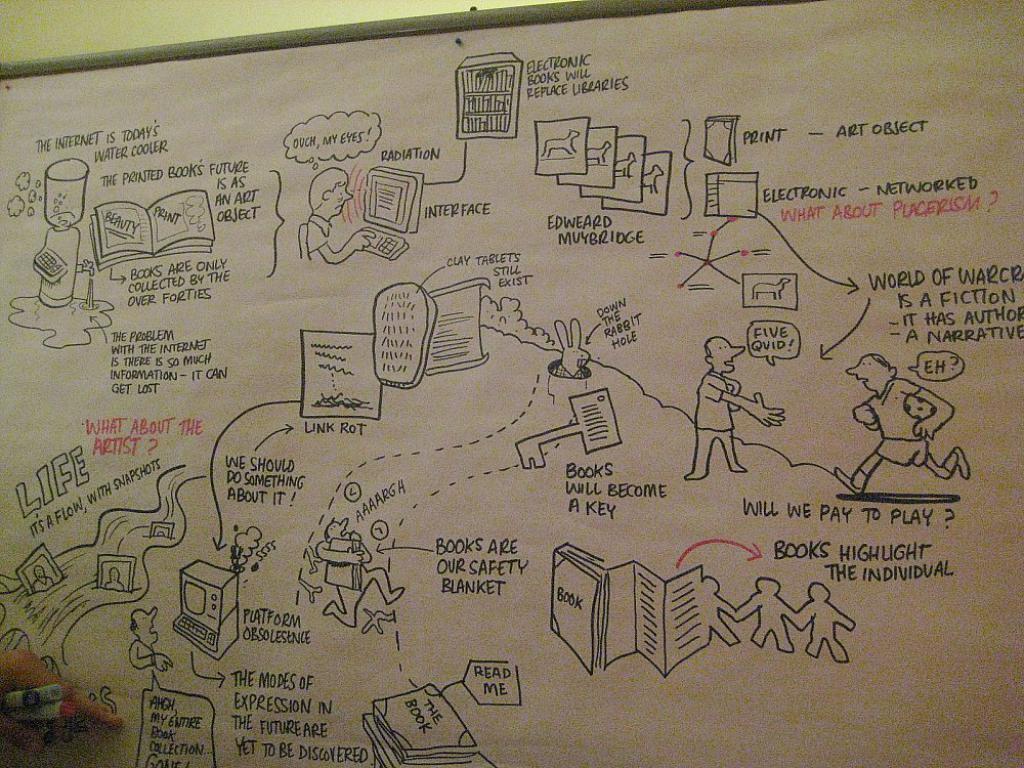What text does the red arrow point to?
Offer a terse response. Books highlight the individual. What will replace libraries?
Keep it short and to the point. Electronic books. 